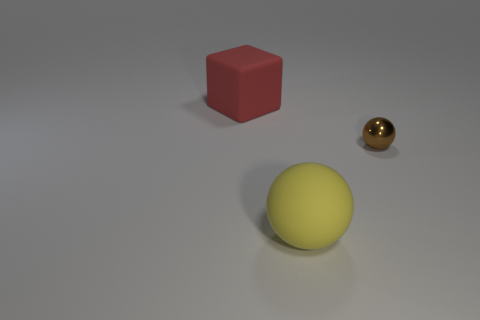The large rubber object that is behind the sphere that is behind the yellow matte object is what color?
Your response must be concise. Red. There is a matte object that is behind the thing in front of the small brown metallic ball; what size is it?
Ensure brevity in your answer.  Large. What number of other objects are there of the same size as the red matte object?
Provide a short and direct response. 1. The large thing on the left side of the large rubber object on the right side of the large matte cube to the left of the brown object is what color?
Your answer should be very brief. Red. What number of other things are the same shape as the large red matte thing?
Make the answer very short. 0. The big thing that is behind the big yellow object has what shape?
Your answer should be compact. Cube. There is a big rubber thing on the right side of the large block; are there any spheres that are behind it?
Offer a very short reply. Yes. There is a object that is behind the big yellow rubber object and to the left of the small brown metallic object; what color is it?
Offer a very short reply. Red. Are there any large red cubes that are in front of the large thing in front of the matte thing behind the big ball?
Make the answer very short. No. There is a shiny thing that is the same shape as the yellow rubber thing; what size is it?
Your answer should be very brief. Small. 